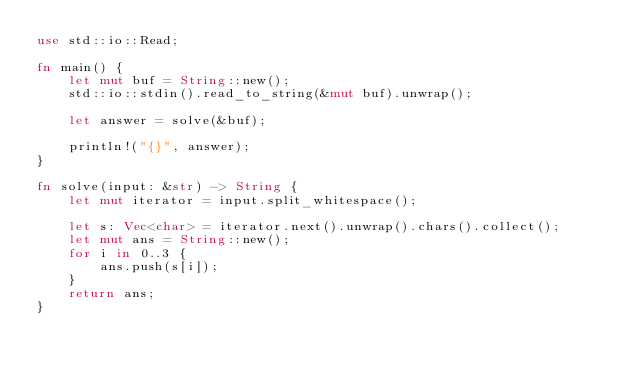<code> <loc_0><loc_0><loc_500><loc_500><_Rust_>use std::io::Read;

fn main() {
    let mut buf = String::new();
    std::io::stdin().read_to_string(&mut buf).unwrap();

    let answer = solve(&buf);

    println!("{}", answer);
}

fn solve(input: &str) -> String {
    let mut iterator = input.split_whitespace();

    let s: Vec<char> = iterator.next().unwrap().chars().collect();
    let mut ans = String::new();
    for i in 0..3 {
        ans.push(s[i]);
    }
    return ans;
}
</code> 